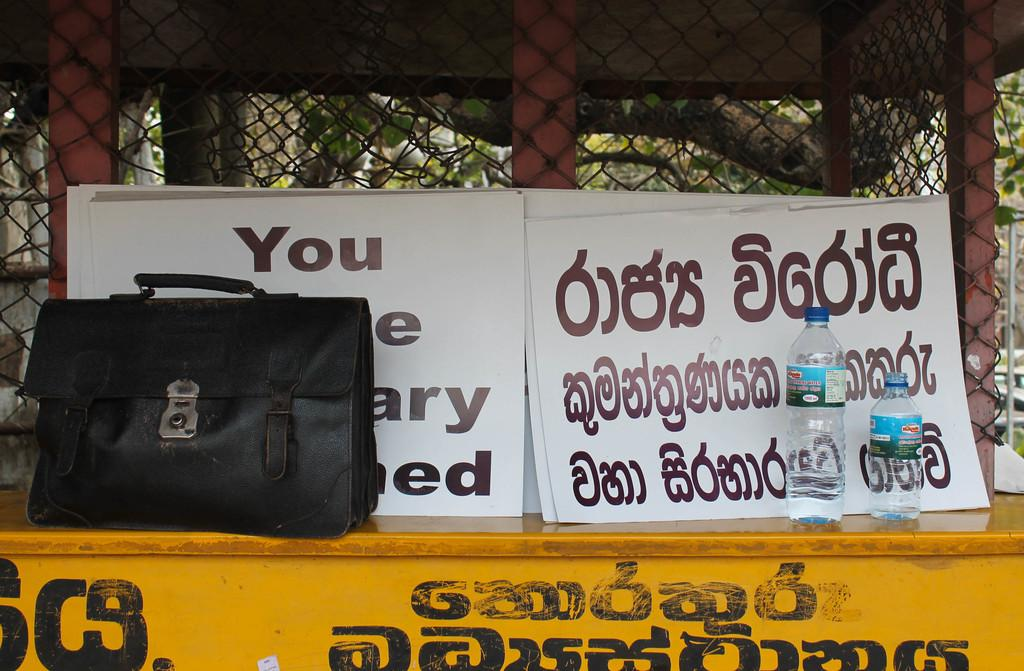What type of barrier can be seen in the image? There is a fence in the image. What type of printed materials are present in the image? There are posters in the image. What type of containers are visible in the image? There are bottles in the image. What type of bag can be seen in the image? There is a black color bag in the image. How many cherries are on top of the black color bag in the image? There are no cherries present in the image. What is the price of the posters in the image? The price of the posters is not mentioned in the image. 